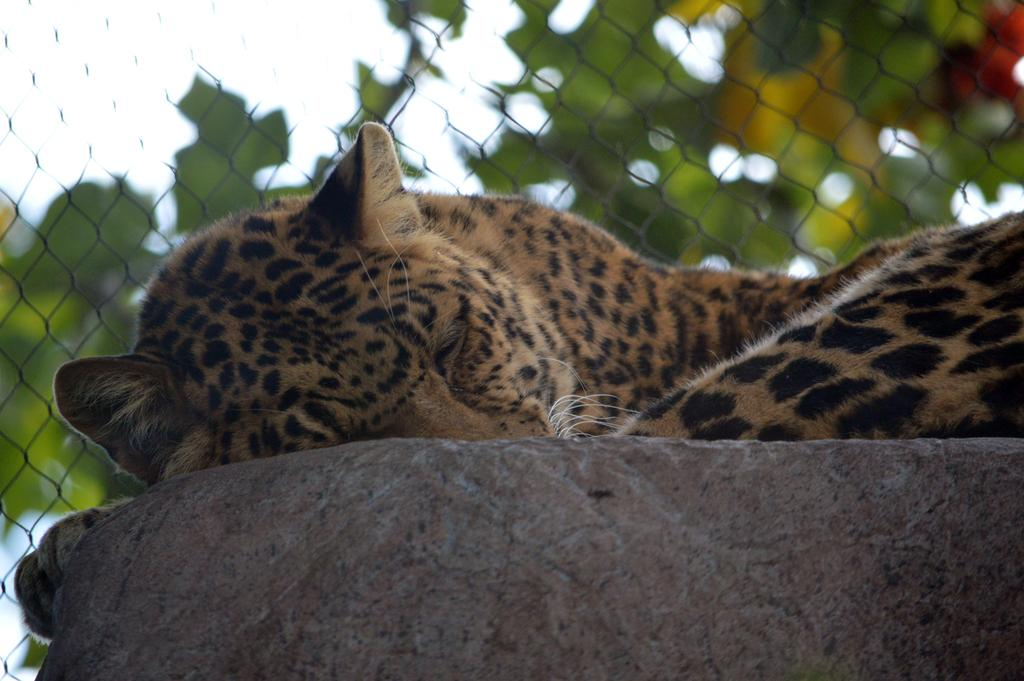What type of animal can be seen in the image? There is an animal in the image, but its specific type cannot be determined from the provided facts. Where is the animal located in the image? The animal is lying on a rock in the image. What is behind the animal in the image? There is a mesh behind the animal in the image. How is the background of the mesh depicted in the image? The background of the mesh is blurred in the image. What type of pin is holding the animal's comfort in place in the image? There is no pin or comfort item present in the image; it features an animal lying on a rock with a mesh behind it. 